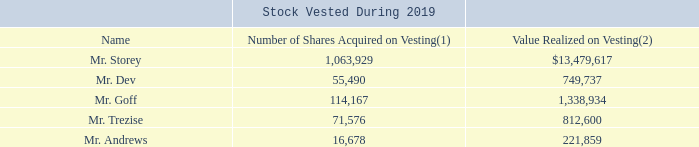Vesting of Equity Awards During 2019
The following table provides details regarding the equity awards held by our named executives that vested during 2019. Restricted stock and restricted stock units were the only equity awards held by our named executives during 2019.
(1) Represents both time-vested and performance-based equity awards that vested during 2019. For details on the payout of our performance-based equity awards, please see “Compensation Discussion and Analysis—Our 2019 Compensation Program and Components of Pay—Grants of Long Term Incentive Compensation—Long Term Incentive Performance Updates” and “—Our Compensation Philosophy Objectives and Linkage to Corporate Strategy—Overview of Pay Elements and Linkage to Compensation Philosophy and Corporate Strategy.”
(2) Based on the closing trading price of the Common Shares on the applicable vesting date.
What is the value realized on vesting based on? The closing trading price of the common shares on the applicable vesting date. What were the equity awards held by named executives during 2019? Restricted stock and restricted stock units. What does the number of shares acquired on vesting represent? Both time-vested and performance-based equity awards that vested during 2019. How many named executives who hold equity awards and vested during 2019 are there? Mr. Storey##Mr. Dev##Mr. Goff##Mr. Trezise##Mr. Andrews
Answer: 5. What is the difference in the value realized on vesting between Mr. Trezise and Mr. Dev?  $812,600-$749,737
Answer: 62863. What is the average number of shares acquired on vesting? (1,063,929+55,490+114,167+71,576+16,678)/5
Answer: 264368. 